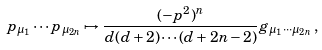<formula> <loc_0><loc_0><loc_500><loc_500>p _ { \mu _ { 1 } } \cdots p _ { \mu _ { 2 n } } \mapsto \frac { ( - p ^ { 2 } ) ^ { n } } { d ( d + 2 ) \cdots ( d + 2 n - 2 ) } g _ { \mu _ { 1 } \cdots \mu _ { 2 n } } \, ,</formula> 